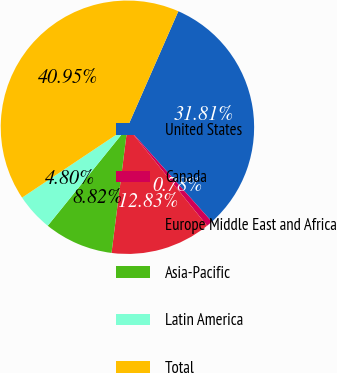<chart> <loc_0><loc_0><loc_500><loc_500><pie_chart><fcel>United States<fcel>Canada<fcel>Europe Middle East and Africa<fcel>Asia-Pacific<fcel>Latin America<fcel>Total<nl><fcel>31.81%<fcel>0.78%<fcel>12.83%<fcel>8.82%<fcel>4.8%<fcel>40.95%<nl></chart> 